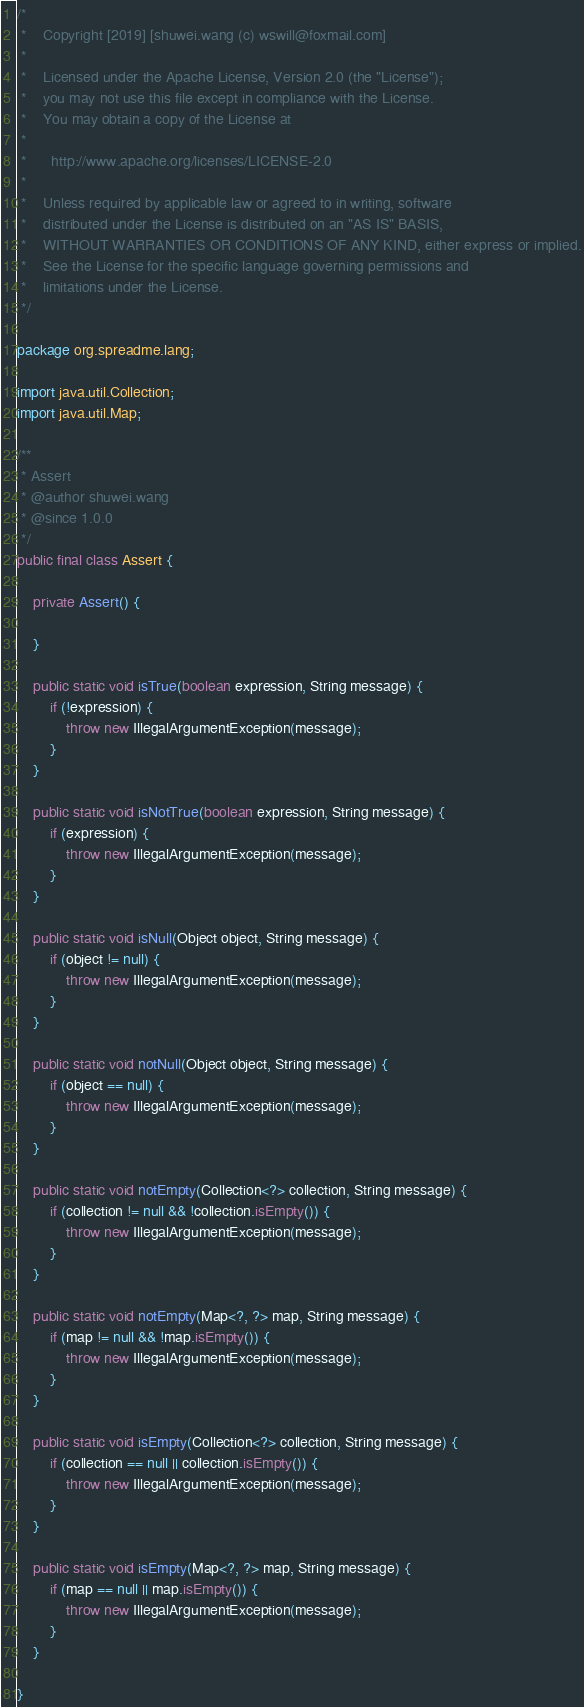Convert code to text. <code><loc_0><loc_0><loc_500><loc_500><_Java_>/*
 *    Copyright [2019] [shuwei.wang (c) wswill@foxmail.com]
 *
 *    Licensed under the Apache License, Version 2.0 (the "License");
 *    you may not use this file except in compliance with the License.
 *    You may obtain a copy of the License at
 *
 *      http://www.apache.org/licenses/LICENSE-2.0
 *
 *    Unless required by applicable law or agreed to in writing, software
 *    distributed under the License is distributed on an "AS IS" BASIS,
 *    WITHOUT WARRANTIES OR CONDITIONS OF ANY KIND, either express or implied.
 *    See the License for the specific language governing permissions and
 *    limitations under the License.
 */

package org.spreadme.lang;

import java.util.Collection;
import java.util.Map;

/**
 * Assert
 * @author shuwei.wang
 * @since 1.0.0
 */
public final class Assert {

	private Assert() {

	}

	public static void isTrue(boolean expression, String message) {
		if (!expression) {
			throw new IllegalArgumentException(message);
		}
	}

	public static void isNotTrue(boolean expression, String message) {
		if (expression) {
			throw new IllegalArgumentException(message);
		}
	}

	public static void isNull(Object object, String message) {
		if (object != null) {
			throw new IllegalArgumentException(message);
		}
	}

	public static void notNull(Object object, String message) {
		if (object == null) {
			throw new IllegalArgumentException(message);
		}
	}

	public static void notEmpty(Collection<?> collection, String message) {
		if (collection != null && !collection.isEmpty()) {
			throw new IllegalArgumentException(message);
		}
	}

	public static void notEmpty(Map<?, ?> map, String message) {
		if (map != null && !map.isEmpty()) {
			throw new IllegalArgumentException(message);
		}
	}

	public static void isEmpty(Collection<?> collection, String message) {
		if (collection == null || collection.isEmpty()) {
			throw new IllegalArgumentException(message);
		}
	}

	public static void isEmpty(Map<?, ?> map, String message) {
		if (map == null || map.isEmpty()) {
			throw new IllegalArgumentException(message);
		}
	}

}
</code> 